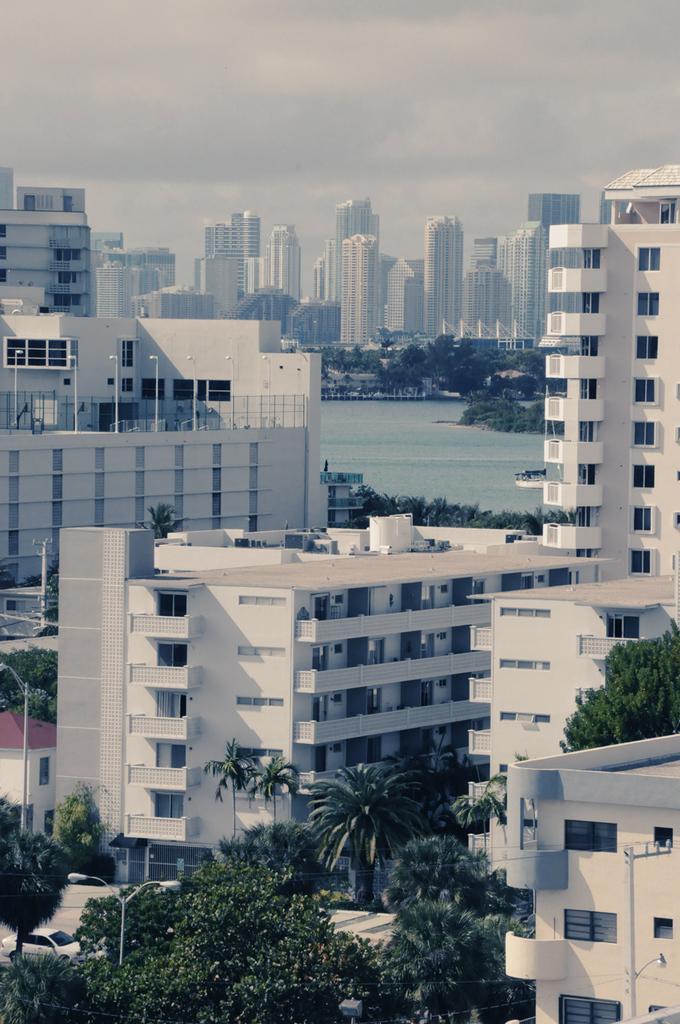Describe this image in one or two sentences. In this image, there are buildings, walls, balconies, windows, railings, trees, poles, street lights, vehicle and some objects. In the background, we can see water, boat, buildings, trees and the sky. 